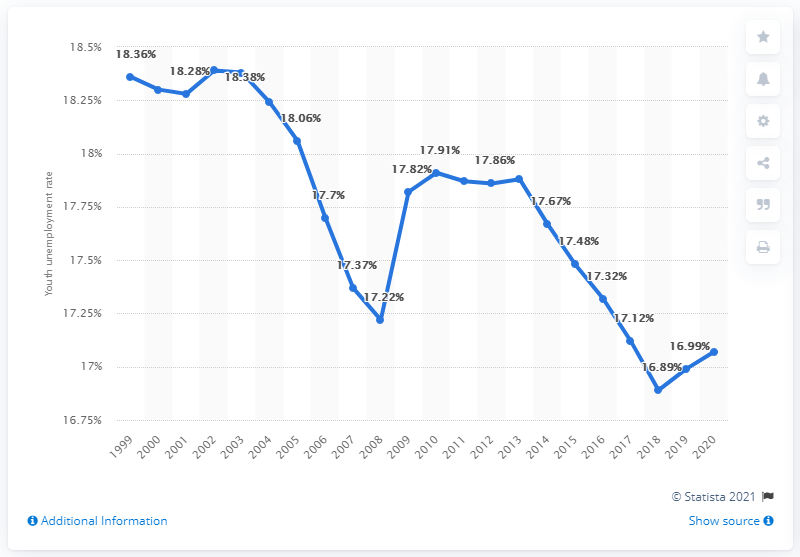Highlight a few significant elements in this photo. In 2020, the youth unemployment rate in Somalia was 17.07%. 